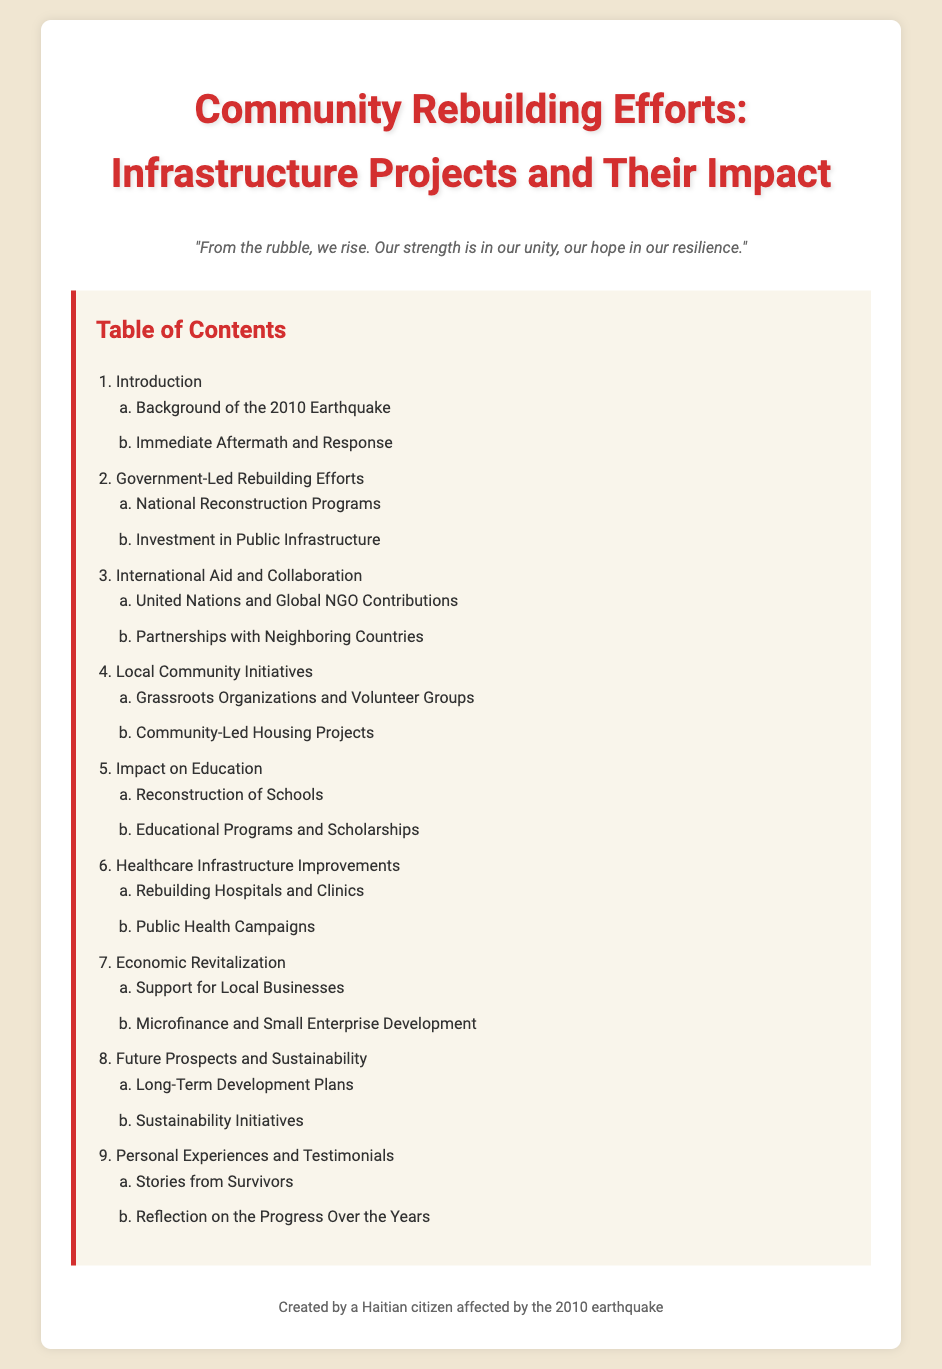What is the title of the document? The title is usually found at the top of the document and indicates the main topic discussed.
Answer: Community Rebuilding Efforts: Infrastructure Projects and Their Impact What is the first section in the Table of Contents? The first section listed provides an overview or introduction to the subject matter.
Answer: Introduction How many sections are there in the Table of Contents? The total sections represent the main topics covered in the document as listed in the Table of Contents.
Answer: Nine Which organization's contributions are mentioned under International Aid and Collaboration? This information highlights the involvement of specific organizations in support efforts after the earthquake.
Answer: United Nations What is one of the focuses of the Government-Led Rebuilding Efforts? This focuses on particular initiatives undertaken by the government to rebuild after the earthquake.
Answer: National Reconstruction Programs What type of projects are included under Local Community Initiatives? This reflects the grassroots efforts made by local groups to contribute to the rebuilding process.
Answer: Community-Led Housing Projects Which section addresses improvements in healthcare? Identifying the section helps in understanding how healthcare has been affected and improved post-earthquake.
Answer: Healthcare Infrastructure Improvements What is the last section mentioned in the Table of Contents? The last section provides personal accounts and perspectives on the rebuilding efforts.
Answer: Personal Experiences and Testimonials What does the quote in the document suggest? The quote typically encapsulates a hopeful perspective on resilience and unity post-disaster.
Answer: Resilience and unity 